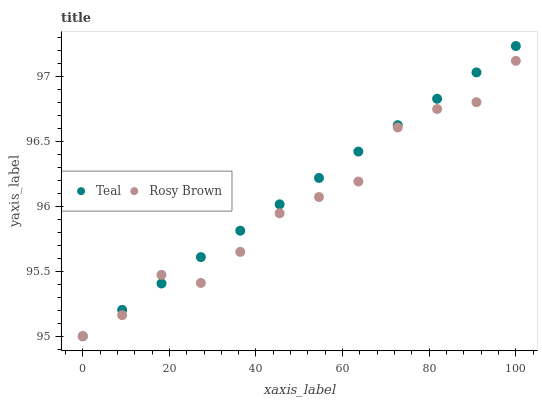Does Rosy Brown have the minimum area under the curve?
Answer yes or no. Yes. Does Teal have the maximum area under the curve?
Answer yes or no. Yes. Does Teal have the minimum area under the curve?
Answer yes or no. No. Is Teal the smoothest?
Answer yes or no. Yes. Is Rosy Brown the roughest?
Answer yes or no. Yes. Is Teal the roughest?
Answer yes or no. No. Does Rosy Brown have the lowest value?
Answer yes or no. Yes. Does Teal have the highest value?
Answer yes or no. Yes. Does Teal intersect Rosy Brown?
Answer yes or no. Yes. Is Teal less than Rosy Brown?
Answer yes or no. No. Is Teal greater than Rosy Brown?
Answer yes or no. No. 